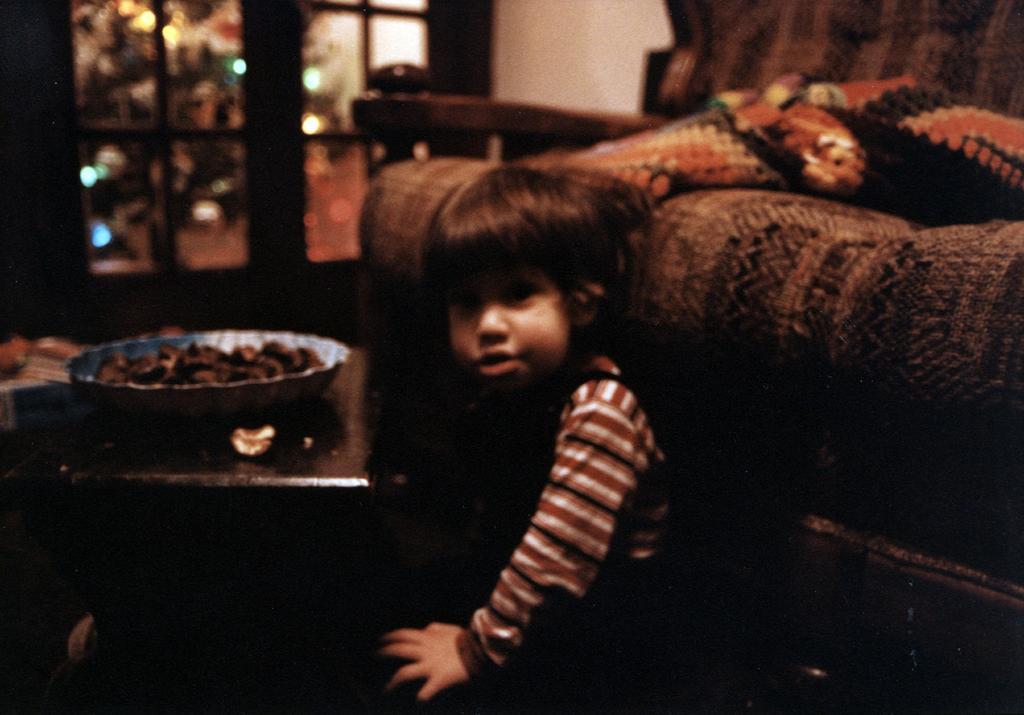Could you give a brief overview of what you see in this image? In the image there is a boy and backsides of him it's a sofa and on left side there is a door and outside the door there is a tree. In front of boy there is teapoy with bowl filled with some food. 